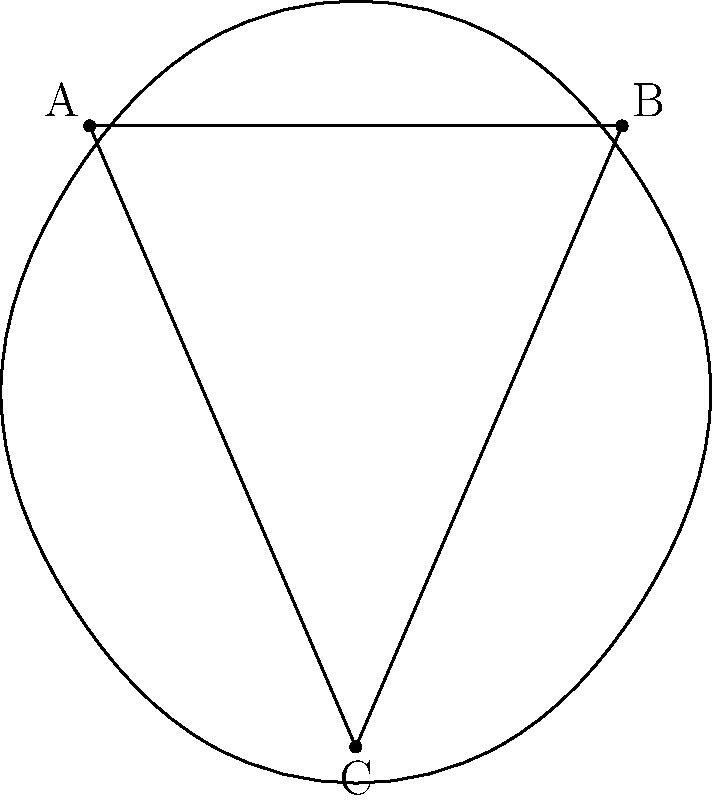On the curved body of your electric guitar, you've drawn a triangle ABC as shown. If the sum of the interior angles of this triangle is 190°, what type of geometry does this represent, and how does it relate to the curvature of the guitar's body? Let's break this down step-by-step:

1. In Euclidean geometry, the sum of the interior angles of a triangle is always 180°. However, in this case, the sum is 190°.

2. When the sum of the interior angles of a triangle is greater than 180°, we are dealing with spherical geometry, a type of non-Euclidean geometry.

3. Spherical geometry occurs on positively curved surfaces. The guitar's body, being convex, represents a positively curved surface.

4. The excess angle (190° - 180° = 10°) is directly related to the curvature of the surface. This is known as the spherical excess.

5. The spherical excess (ε) is given by the formula:
   $$ \varepsilon = A / R^2 $$
   where A is the area of the triangle and R is the radius of the sphere.

6. The greater the curvature (smaller radius), the larger the spherical excess.

7. In this case, the 10° excess indicates that the guitar's body has a significant curvature, enough to noticeably affect the geometry drawn on its surface.

8. This phenomenon is similar to what happens when drawing triangles on a globe - the sum of their angles will always exceed 180°.
Answer: Spherical geometry; reflects guitar's convex curvature 